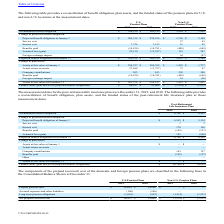From Cts Corporation's financial document, Which years does the table provide information for the components of the prepaid (accrued) cost of the domestic and foreign pension plans ? The document shows two values: 2019 and 2018. From the document: "2019 2018 2019 2018 2019 2018 2019 2018..." Also, What was the Prepaid pension asset for U.S. Pension Plans in 2018? According to the financial document, 54,100 (in thousands). The relevant text states: "Prepaid pension asset $ 62,082 $ 54,100 $ — $ —..." Also, What was the Long-term pension obligations for Non-U.S. Pension Plans in 2018? According to the financial document, (1,331) (in thousands). The relevant text states: "ong-term pension obligations (1,045) (992) (1,214) (1,331)..." Also, can you calculate: What was the change in the Prepaid pension asset for U.S Pension Plans between 2018 and 2019? Based on the calculation: 62,082-54,100, the result is 7982 (in thousands). This is based on the information: "Prepaid pension asset $ 62,082 $ 54,100 $ — $ — Prepaid pension asset $ 62,082 $ 54,100 $ — $ —..." The key data points involved are: 54,100, 62,082. Also, can you calculate: What was the change in the Net prepaid (accrued) cost for U.S. Pension Plans between 2018 and 2019? Based on the calculation: 60,937-53,008, the result is 7929 (in thousands). This is based on the information: "plan assets less projected benefit obligations) $ 60,937 $ 53,008 $ (1,214) $ (1,331) ts less projected benefit obligations) $ 60,937 $ 53,008 $ (1,214) $ (1,331)..." The key data points involved are: 53,008, 60,937. Also, can you calculate: What was the percentage change in Long-term pension obligations for U.S. Pension Plans between 2018 and 2019? To answer this question, I need to perform calculations using the financial data. The calculation is: (-1,045-(992))/-992, which equals 5.34 (percentage). This is based on the information: "Long-term pension obligations (1,045) (992) (1,214) (1,331) Long-term pension obligations (1,045) (992) (1,214) (1,331)..." The key data points involved are: 1,045, 992. 